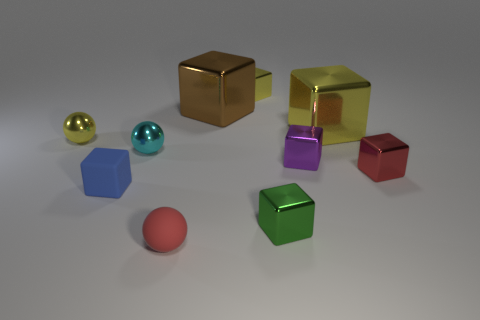Subtract all yellow blocks. How many blocks are left? 5 Subtract all large shiny cubes. How many cubes are left? 5 Subtract 2 blocks. How many blocks are left? 5 Subtract all brown blocks. Subtract all purple balls. How many blocks are left? 6 Subtract all cubes. How many objects are left? 3 Subtract 1 green cubes. How many objects are left? 9 Subtract all yellow shiny cubes. Subtract all small blue blocks. How many objects are left? 7 Add 6 blue rubber things. How many blue rubber things are left? 7 Add 8 yellow rubber objects. How many yellow rubber objects exist? 8 